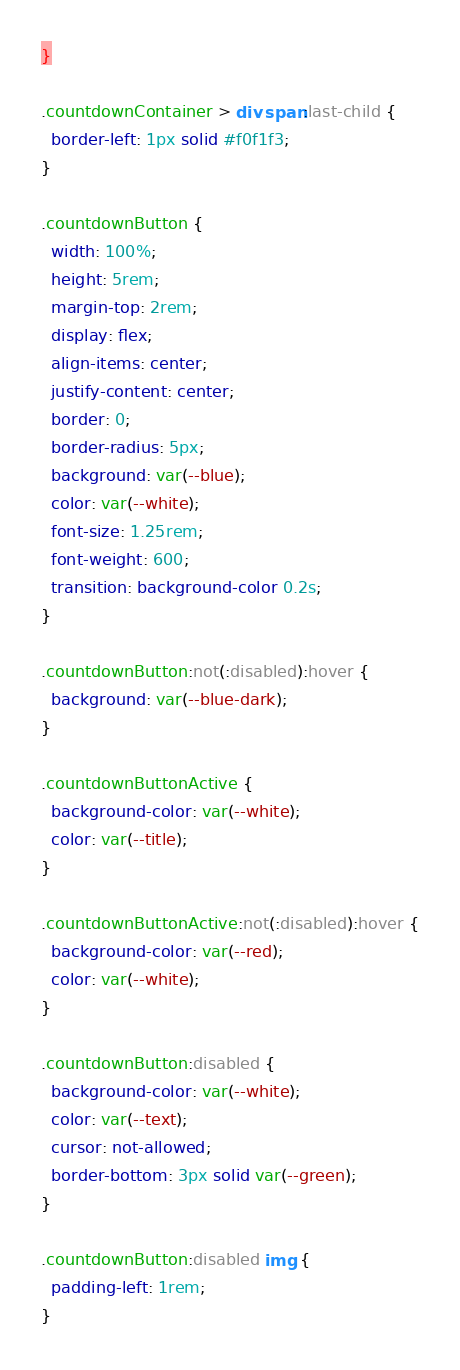<code> <loc_0><loc_0><loc_500><loc_500><_CSS_>}

.countdownContainer > div span:last-child {
  border-left: 1px solid #f0f1f3;
}

.countdownButton {
  width: 100%;
  height: 5rem;
  margin-top: 2rem;
  display: flex;
  align-items: center;
  justify-content: center;
  border: 0;
  border-radius: 5px;
  background: var(--blue);
  color: var(--white);
  font-size: 1.25rem;
  font-weight: 600;
  transition: background-color 0.2s;
}

.countdownButton:not(:disabled):hover {
  background: var(--blue-dark);
}

.countdownButtonActive {
  background-color: var(--white);
  color: var(--title);
}

.countdownButtonActive:not(:disabled):hover {
  background-color: var(--red);
  color: var(--white);
}

.countdownButton:disabled {
  background-color: var(--white);
  color: var(--text);
  cursor: not-allowed;
  border-bottom: 3px solid var(--green);
}

.countdownButton:disabled img {
  padding-left: 1rem;
}
</code> 